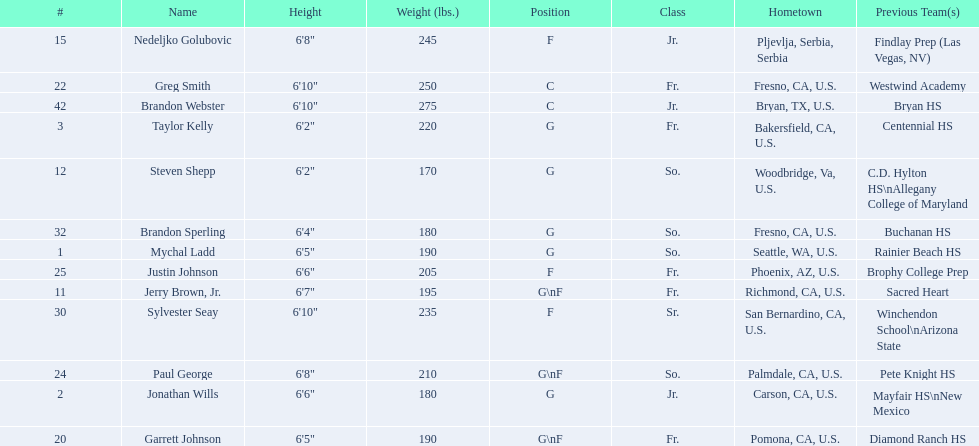Which players are forwards? Nedeljko Golubovic, Paul George, Justin Johnson, Sylvester Seay. What are the heights of these players? Nedeljko Golubovic, 6'8", Paul George, 6'8", Justin Johnson, 6'6", Sylvester Seay, 6'10". Of these players, who is the shortest? Justin Johnson. 